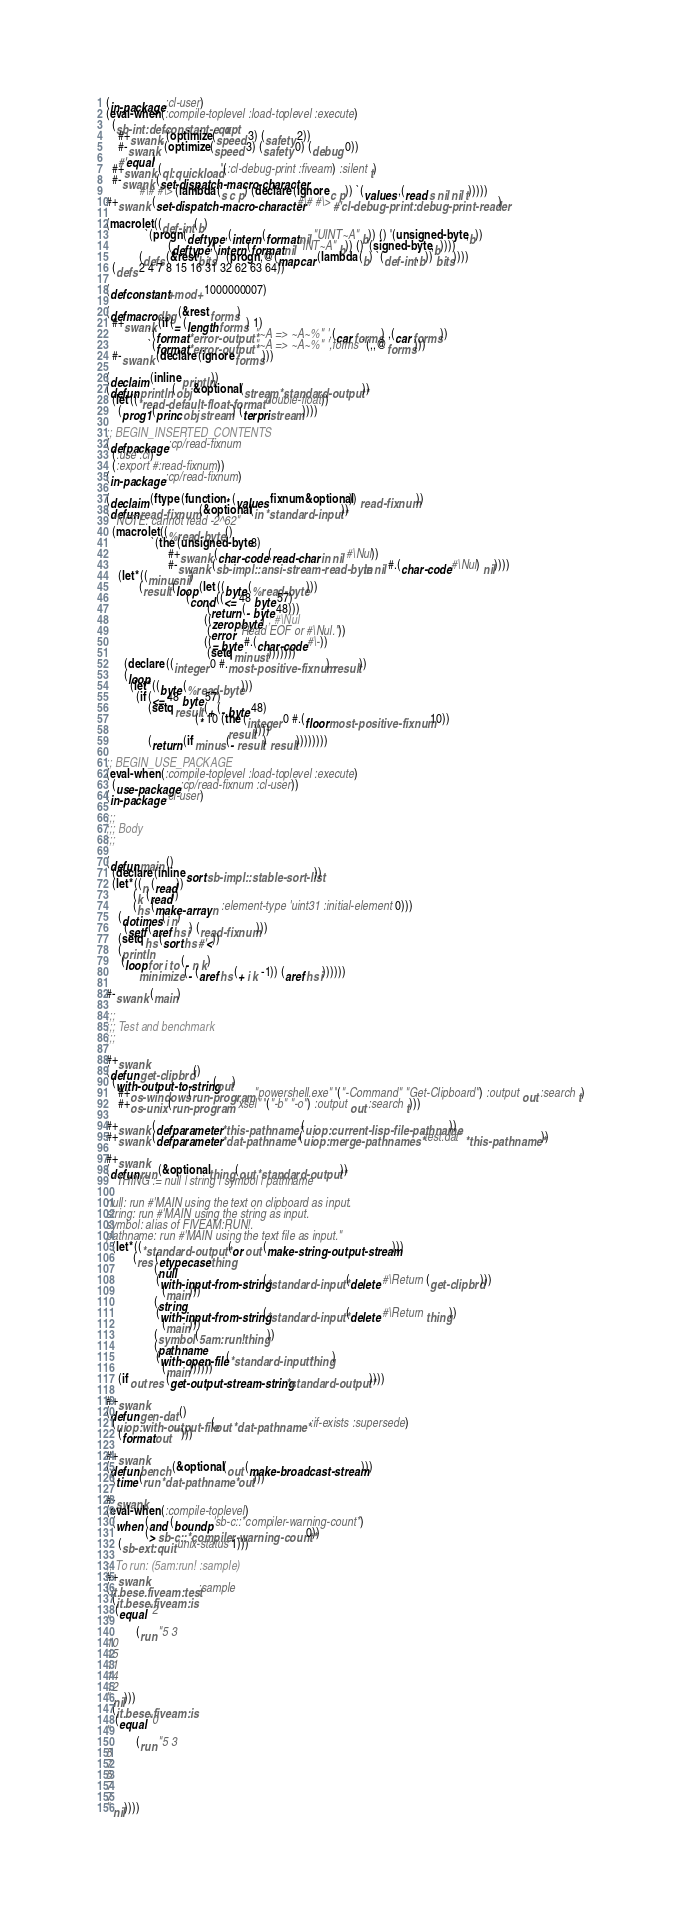<code> <loc_0><loc_0><loc_500><loc_500><_Lisp_>(in-package :cl-user)
(eval-when (:compile-toplevel :load-toplevel :execute)
  (sb-int:defconstant-eqx opt
    #+swank '(optimize (speed 3) (safety 2))
    #-swank '(optimize (speed 3) (safety 0) (debug 0))
    #'equal)
  #+swank (ql:quickload '(:cl-debug-print :fiveam) :silent t)
  #-swank (set-dispatch-macro-character
           #\# #\> (lambda (s c p) (declare (ignore c p)) `(values ,(read s nil nil t)))))
#+swank (set-dispatch-macro-character #\# #\> #'cl-debug-print:debug-print-reader)

(macrolet ((def-int (b)
             `(progn (deftype ,(intern (format nil "UINT~A" b)) () '(unsigned-byte ,b))
                     (deftype ,(intern (format nil "INT~A" b)) () '(signed-byte ,b))))
           (defs (&rest bits) `(progn ,@(mapcar (lambda (b) `(def-int ,b)) bits))))
  (defs 2 4 7 8 15 16 31 32 62 63 64))

(defconstant +mod+ 1000000007)

(defmacro dbg (&rest forms)
  #+swank (if (= (length forms) 1)
              `(format *error-output* "~A => ~A~%" ',(car forms) ,(car forms))
              `(format *error-output* "~A => ~A~%" ',forms `(,,@forms)))
  #-swank (declare (ignore forms)))

(declaim (inline println))
(defun println (obj &optional (stream *standard-output*))
  (let ((*read-default-float-format* 'double-float))
    (prog1 (princ obj stream) (terpri stream))))

;; BEGIN_INSERTED_CONTENTS
(defpackage :cp/read-fixnum
  (:use :cl)
  (:export #:read-fixnum))
(in-package :cp/read-fixnum)

(declaim (ftype (function * (values fixnum &optional)) read-fixnum))
(defun read-fixnum (&optional (in *standard-input*))
  "NOTE: cannot read -2^62"
  (macrolet ((%read-byte ()
               `(the (unsigned-byte 8)
                     #+swank (char-code (read-char in nil #\Nul))
                     #-swank (sb-impl::ansi-stream-read-byte in nil #.(char-code #\Nul) nil))))
    (let* ((minus nil)
           (result (loop (let ((byte (%read-byte)))
                           (cond ((<= 48 byte 57)
                                  (return (- byte 48)))
                                 ((zerop byte) ; #\Nul
                                  (error "Read EOF or #\Nul."))
                                 ((= byte #.(char-code #\-))
                                  (setq minus t)))))))
      (declare ((integer 0 #.most-positive-fixnum) result))
      (loop
        (let* ((byte (%read-byte)))
          (if (<= 48 byte 57)
              (setq result (+ (- byte 48)
                              (* 10 (the (integer 0 #.(floor most-positive-fixnum 10))
                                         result))))
              (return (if minus (- result) result))))))))

;; BEGIN_USE_PACKAGE
(eval-when (:compile-toplevel :load-toplevel :execute)
  (use-package :cp/read-fixnum :cl-user))
(in-package :cl-user)

;;;
;;; Body
;;;

(defun main ()
  (declare (inline sort sb-impl::stable-sort-list))
  (let* ((n (read))
         (k (read))
         (hs (make-array n :element-type 'uint31 :initial-element 0)))
    (dotimes (i n)
      (setf (aref hs i) (read-fixnum)))
    (setq hs (sort hs #'<))
    (println
     (loop for i to (- n k)
           minimize (- (aref hs (+ i k -1)) (aref hs i))))))

#-swank (main)

;;;
;;; Test and benchmark
;;;

#+swank
(defun get-clipbrd ()
  (with-output-to-string (out)
    #+os-windows (run-program "powershell.exe" '("-Command" "Get-Clipboard") :output out :search t)
    #+os-unix (run-program "xsel" '("-b" "-o") :output out :search t)))

#+swank (defparameter *this-pathname* (uiop:current-lisp-file-pathname))
#+swank (defparameter *dat-pathname* (uiop:merge-pathnames* "test.dat" *this-pathname*))

#+swank
(defun run (&optional thing (out *standard-output*))
  "THING := null | string | symbol | pathname

null: run #'MAIN using the text on clipboard as input.
string: run #'MAIN using the string as input.
symbol: alias of FIVEAM:RUN!.
pathname: run #'MAIN using the text file as input."
  (let* ((*standard-output* (or out (make-string-output-stream)))
         (res (etypecase thing
                (null
                 (with-input-from-string (*standard-input* (delete #\Return (get-clipbrd)))
                   (main)))
                (string
                 (with-input-from-string (*standard-input* (delete #\Return thing))
                   (main)))
                (symbol (5am:run! thing))
                (pathname
                 (with-open-file (*standard-input* thing)
                   (main))))))
    (if out res (get-output-stream-string *standard-output*))))

#+swank
(defun gen-dat ()
  (uiop:with-output-file (out *dat-pathname* :if-exists :supersede)
    (format out "")))

#+swank
(defun bench (&optional (out (make-broadcast-stream)))
  (time (run *dat-pathname* out)))

#-swank
(eval-when (:compile-toplevel)
  (when (and (boundp 'sb-c::*compiler-warning-count*)
             (> sb-c::*compiler-warning-count* 0))
    (sb-ext:quit :unix-status 1)))

;; To run: (5am:run! :sample)
#+swank
(it.bese.fiveam:test :sample
  (it.bese.fiveam:is
   (equal "2
"
          (run "5 3
10
15
11
14
12
" nil)))
  (it.bese.fiveam:is
   (equal "0
"
          (run "5 3
5
7
5
7
7
" nil))))
</code> 